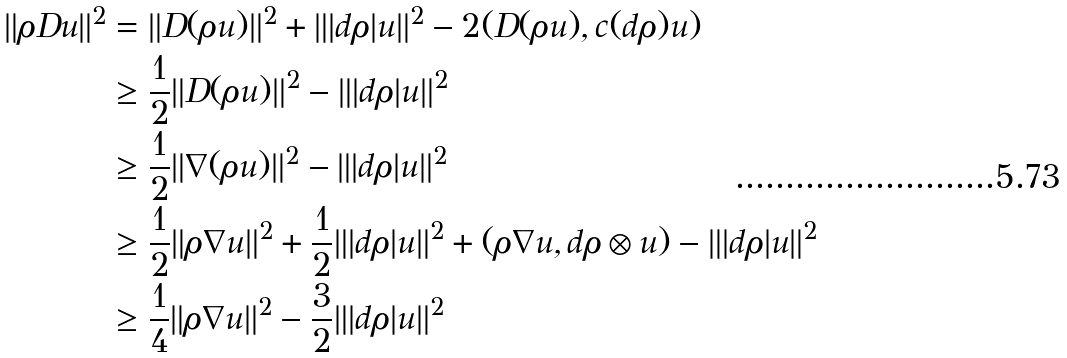Convert formula to latex. <formula><loc_0><loc_0><loc_500><loc_500>\| \rho D u \| ^ { 2 } & = \| D ( \rho u ) \| ^ { 2 } + \| | d \rho | u \| ^ { 2 } - 2 ( D ( \rho u ) , c ( d \rho ) u ) \\ & \geq \frac { 1 } { 2 } \| D ( \rho u ) \| ^ { 2 } - \| | d \rho | u \| ^ { 2 } \\ & \geq \frac { 1 } { 2 } \| \nabla ( \rho u ) \| ^ { 2 } - \| | d \rho | u \| ^ { 2 } \\ & \geq \frac { 1 } { 2 } \| \rho \nabla u \| ^ { 2 } + \frac { 1 } { 2 } \| | d \rho | u \| ^ { 2 } + ( \rho \nabla u , d \rho \otimes u ) - \| | d \rho | u \| ^ { 2 } \\ & \geq \frac { 1 } { 4 } \| \rho \nabla u \| ^ { 2 } - \frac { 3 } { 2 } \| | d \rho | u \| ^ { 2 }</formula> 